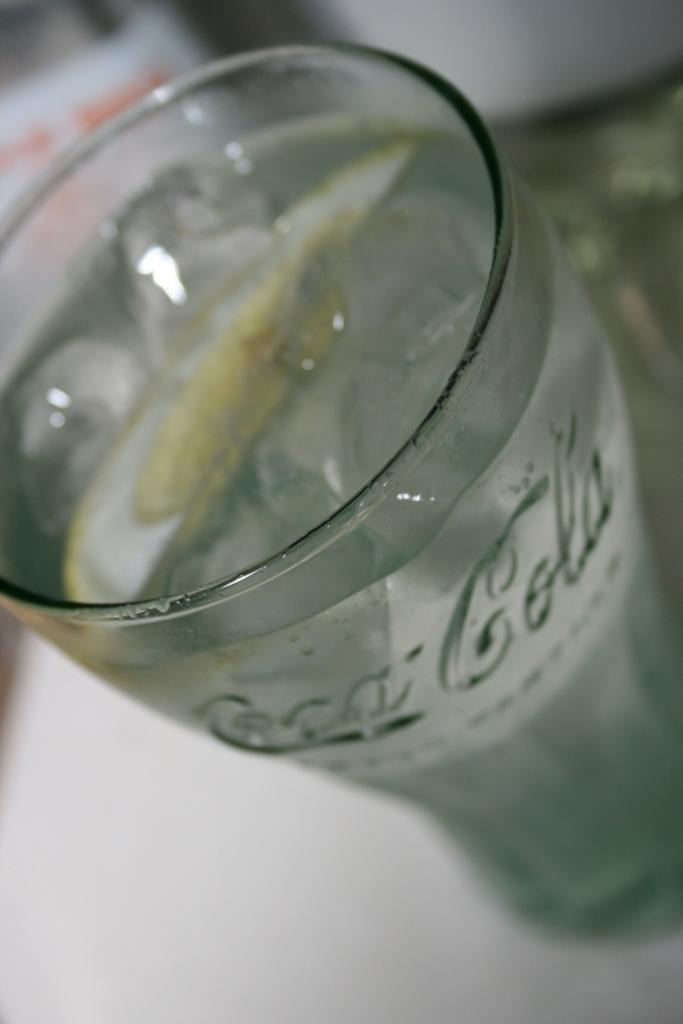What is inside the glass that is visible in the image? There is a drink in the glass that is visible in the image. Where is the glass placed in the image? The glass is placed on a platform in the image. What can be seen in the background of the image? There are blurry objects in the background of the image. What type of cream can be seen on the tongue of the person in the image? There is no person or tongue visible in the image; it only shows a glass with a drink placed on a platform. 